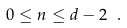Convert formula to latex. <formula><loc_0><loc_0><loc_500><loc_500>0 \leq n \leq d - 2 \ .</formula> 